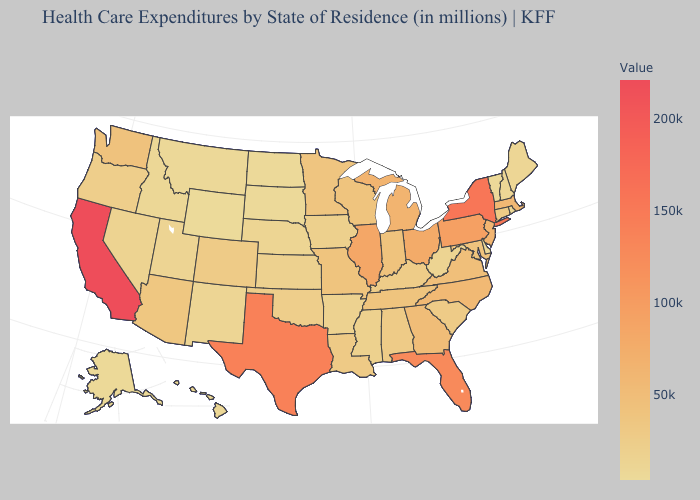Does Nebraska have a lower value than Florida?
Give a very brief answer. Yes. Does Kentucky have the lowest value in the USA?
Keep it brief. No. Does Wyoming have the lowest value in the USA?
Answer briefly. Yes. Which states hav the highest value in the West?
Give a very brief answer. California. Which states have the lowest value in the MidWest?
Be succinct. North Dakota. 